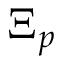Convert formula to latex. <formula><loc_0><loc_0><loc_500><loc_500>\Xi _ { p }</formula> 